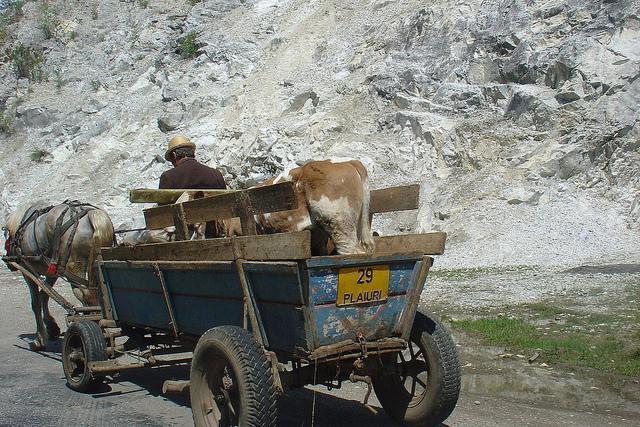How many oxen are in the photo?
Give a very brief answer. 1. How many cows are there?
Give a very brief answer. 1. How many ties is this man wearing?
Give a very brief answer. 0. 